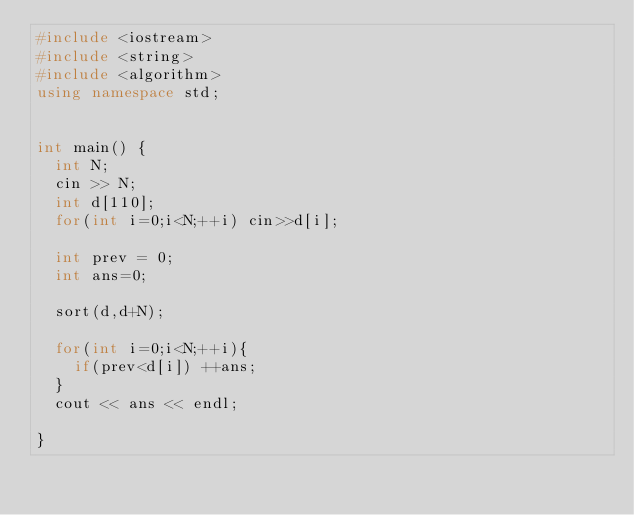Convert code to text. <code><loc_0><loc_0><loc_500><loc_500><_C++_>#include <iostream>
#include <string>
#include <algorithm>
using namespace std;


int main() {
  int N;
  cin >> N;
  int d[110];
  for(int i=0;i<N;++i) cin>>d[i];
  
  int prev = 0;
  int ans=0;
  
  sort(d,d+N);
  
  for(int i=0;i<N;++i){
    if(prev<d[i]) ++ans;
  }
  cout << ans << endl;

}
</code> 